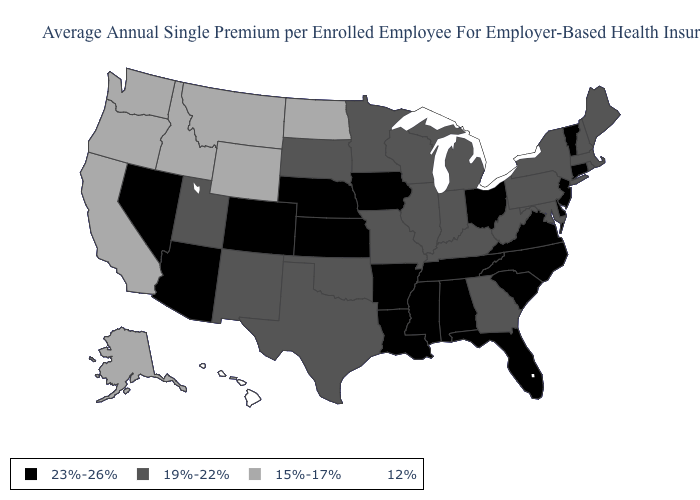Name the states that have a value in the range 19%-22%?
Keep it brief. Georgia, Illinois, Indiana, Kentucky, Maine, Maryland, Massachusetts, Michigan, Minnesota, Missouri, New Hampshire, New Mexico, New York, Oklahoma, Pennsylvania, Rhode Island, South Dakota, Texas, Utah, West Virginia, Wisconsin. What is the value of Florida?
Concise answer only. 23%-26%. Which states have the lowest value in the MidWest?
Give a very brief answer. North Dakota. What is the lowest value in states that border Texas?
Quick response, please. 19%-22%. What is the value of Rhode Island?
Give a very brief answer. 19%-22%. Which states have the lowest value in the USA?
Write a very short answer. Hawaii. What is the highest value in the West ?
Give a very brief answer. 23%-26%. Name the states that have a value in the range 19%-22%?
Answer briefly. Georgia, Illinois, Indiana, Kentucky, Maine, Maryland, Massachusetts, Michigan, Minnesota, Missouri, New Hampshire, New Mexico, New York, Oklahoma, Pennsylvania, Rhode Island, South Dakota, Texas, Utah, West Virginia, Wisconsin. What is the value of New Mexico?
Concise answer only. 19%-22%. Does the map have missing data?
Be succinct. No. Name the states that have a value in the range 19%-22%?
Short answer required. Georgia, Illinois, Indiana, Kentucky, Maine, Maryland, Massachusetts, Michigan, Minnesota, Missouri, New Hampshire, New Mexico, New York, Oklahoma, Pennsylvania, Rhode Island, South Dakota, Texas, Utah, West Virginia, Wisconsin. Does the first symbol in the legend represent the smallest category?
Quick response, please. No. Name the states that have a value in the range 23%-26%?
Quick response, please. Alabama, Arizona, Arkansas, Colorado, Connecticut, Delaware, Florida, Iowa, Kansas, Louisiana, Mississippi, Nebraska, Nevada, New Jersey, North Carolina, Ohio, South Carolina, Tennessee, Vermont, Virginia. Which states have the lowest value in the West?
Keep it brief. Hawaii. Name the states that have a value in the range 12%?
Keep it brief. Hawaii. 